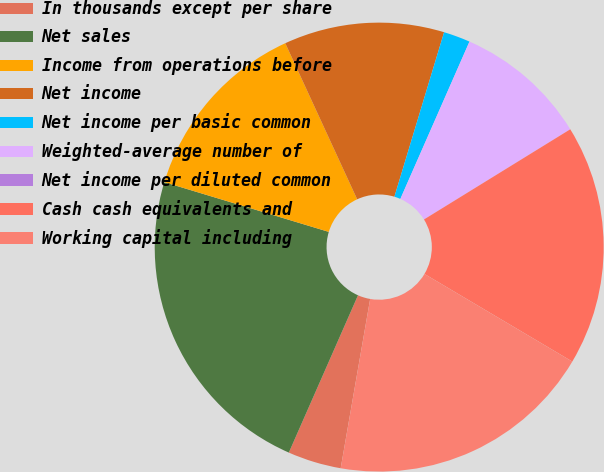<chart> <loc_0><loc_0><loc_500><loc_500><pie_chart><fcel>In thousands except per share<fcel>Net sales<fcel>Income from operations before<fcel>Net income<fcel>Net income per basic common<fcel>Weighted-average number of<fcel>Net income per diluted common<fcel>Cash cash equivalents and<fcel>Working capital including<nl><fcel>3.85%<fcel>23.08%<fcel>13.46%<fcel>11.54%<fcel>1.92%<fcel>9.62%<fcel>0.0%<fcel>17.31%<fcel>19.23%<nl></chart> 